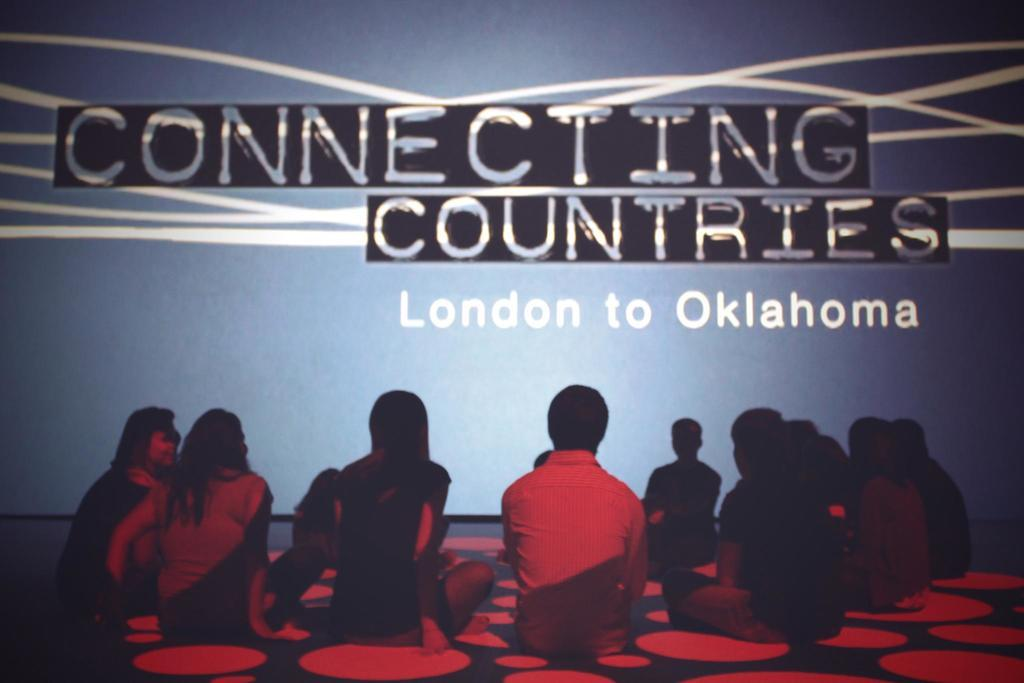What is the composition of the group in the image? There is a group of boys and girls in the image. How are the group members positioned in the image? The group is sitting on the ground. What can be seen in the background of the image? There is a big screen in the image. What message is displayed on the big screen? The big screen has the text "connecting countries" written on it. What type of rain is falling on the group in the image? There is no rain present in the image; the group is sitting on the ground with a big screen in the background. 